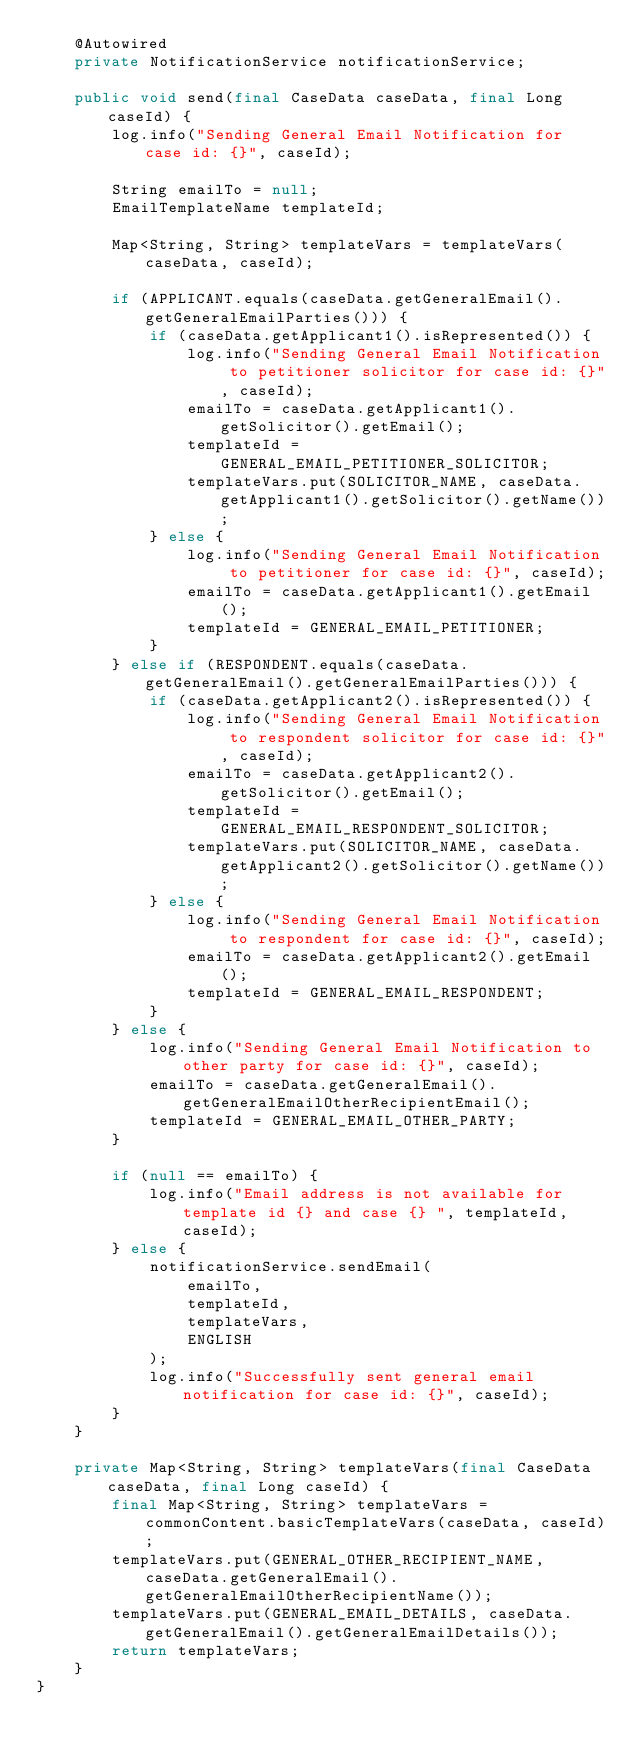<code> <loc_0><loc_0><loc_500><loc_500><_Java_>    @Autowired
    private NotificationService notificationService;

    public void send(final CaseData caseData, final Long caseId) {
        log.info("Sending General Email Notification for case id: {}", caseId);

        String emailTo = null;
        EmailTemplateName templateId;

        Map<String, String> templateVars = templateVars(caseData, caseId);

        if (APPLICANT.equals(caseData.getGeneralEmail().getGeneralEmailParties())) {
            if (caseData.getApplicant1().isRepresented()) {
                log.info("Sending General Email Notification to petitioner solicitor for case id: {}", caseId);
                emailTo = caseData.getApplicant1().getSolicitor().getEmail();
                templateId = GENERAL_EMAIL_PETITIONER_SOLICITOR;
                templateVars.put(SOLICITOR_NAME, caseData.getApplicant1().getSolicitor().getName());
            } else {
                log.info("Sending General Email Notification to petitioner for case id: {}", caseId);
                emailTo = caseData.getApplicant1().getEmail();
                templateId = GENERAL_EMAIL_PETITIONER;
            }
        } else if (RESPONDENT.equals(caseData.getGeneralEmail().getGeneralEmailParties())) {
            if (caseData.getApplicant2().isRepresented()) {
                log.info("Sending General Email Notification to respondent solicitor for case id: {}", caseId);
                emailTo = caseData.getApplicant2().getSolicitor().getEmail();
                templateId = GENERAL_EMAIL_RESPONDENT_SOLICITOR;
                templateVars.put(SOLICITOR_NAME, caseData.getApplicant2().getSolicitor().getName());
            } else {
                log.info("Sending General Email Notification to respondent for case id: {}", caseId);
                emailTo = caseData.getApplicant2().getEmail();
                templateId = GENERAL_EMAIL_RESPONDENT;
            }
        } else {
            log.info("Sending General Email Notification to other party for case id: {}", caseId);
            emailTo = caseData.getGeneralEmail().getGeneralEmailOtherRecipientEmail();
            templateId = GENERAL_EMAIL_OTHER_PARTY;
        }

        if (null == emailTo) {
            log.info("Email address is not available for template id {} and case {} ", templateId, caseId);
        } else {
            notificationService.sendEmail(
                emailTo,
                templateId,
                templateVars,
                ENGLISH
            );
            log.info("Successfully sent general email notification for case id: {}", caseId);
        }
    }

    private Map<String, String> templateVars(final CaseData caseData, final Long caseId) {
        final Map<String, String> templateVars = commonContent.basicTemplateVars(caseData, caseId);
        templateVars.put(GENERAL_OTHER_RECIPIENT_NAME, caseData.getGeneralEmail().getGeneralEmailOtherRecipientName());
        templateVars.put(GENERAL_EMAIL_DETAILS, caseData.getGeneralEmail().getGeneralEmailDetails());
        return templateVars;
    }
}
</code> 